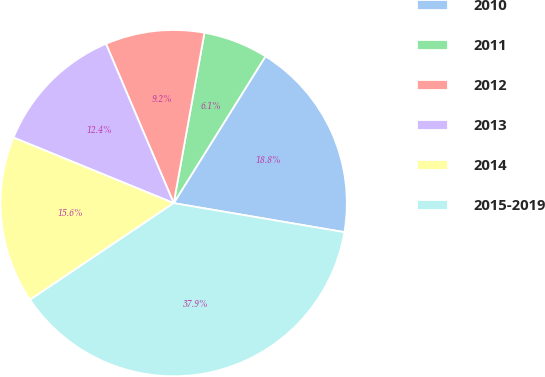Convert chart. <chart><loc_0><loc_0><loc_500><loc_500><pie_chart><fcel>2010<fcel>2011<fcel>2012<fcel>2013<fcel>2014<fcel>2015-2019<nl><fcel>18.79%<fcel>6.05%<fcel>9.24%<fcel>12.42%<fcel>15.61%<fcel>37.89%<nl></chart> 